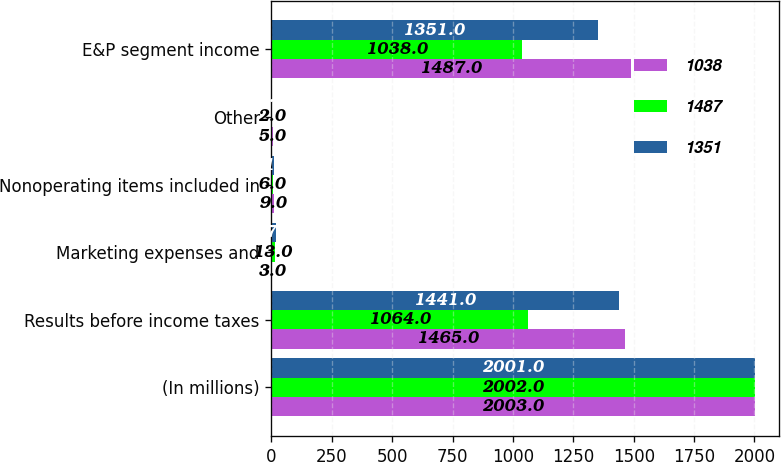Convert chart to OTSL. <chart><loc_0><loc_0><loc_500><loc_500><stacked_bar_chart><ecel><fcel>(In millions)<fcel>Results before income taxes<fcel>Marketing expenses and<fcel>Nonoperating items included in<fcel>Other<fcel>E&P segment income<nl><fcel>1038<fcel>2003<fcel>1465<fcel>3<fcel>9<fcel>5<fcel>1487<nl><fcel>1487<fcel>2002<fcel>1064<fcel>13<fcel>6<fcel>2<fcel>1038<nl><fcel>1351<fcel>2001<fcel>1441<fcel>17<fcel>11<fcel>3<fcel>1351<nl></chart> 